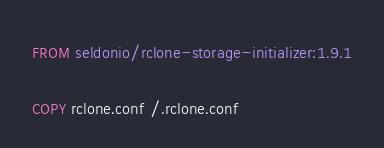<code> <loc_0><loc_0><loc_500><loc_500><_Dockerfile_>FROM seldonio/rclone-storage-initializer:1.9.1

COPY rclone.conf /.rclone.conf</code> 